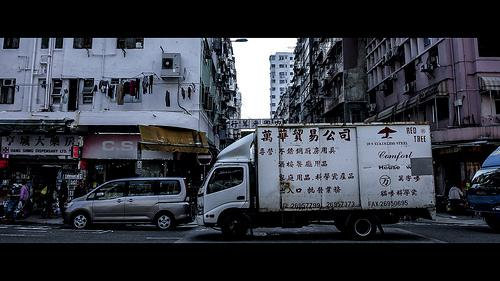Narrate the scene depicted in the image in one sentence. A busy street with a minivan driving past parked trucks, a person standing on the sidewalk, and an array of buildings providing a diverse architectural backdrop. Briefly explain the vehicles in the image and their positions. There are three vehicles on the street: a grey minivan driving down, a parked silver van, and a white box truck with Chinese writing on the side. Explain the setting and the objects captured in the image. The image showcases a busy urban street with a grey minivan, a white truck with Chinese text, and a person standing on the sidewalk, surrounded by various buildings. In one sentence, describe what catches your eye in the image. A red sign on a white building pops out amidst the busy street with various vehicles, such as a grey minivan and a white truck with Chinese text. Briefly describe the ambiance and the elements that make up the image. An urban atmosphere is depicted through the presence of diverse vehicles, buildings with unique colors and text, and a person standing by the sidewalk. Illustrate one noticeable detail in the image. A white moving truck on the street has red Chinese text written on its side, standing out among other vehicles and buildings. Describe the most distinctive aspect of the image. There's a white moving truck with red Chinese text parked on the street near a dirty pink building and a tall white apartment building. Mention a noteworthy feature related to the buildings in the image. An old white building with a red Chinese sign is seen prominently among various other buildings, including a tall white apartment structure. Mention the primary object present in the image and its surroundings. A grey minivan is driving down the road in front of multiple buildings, including a white apartment building and an old white building with red Chinese text. Highlight an interesting aspect of the image. Clothes hang on a drying rack in the vicinity of an old, dirty pink building, adding a personal touch to the urban setting. 